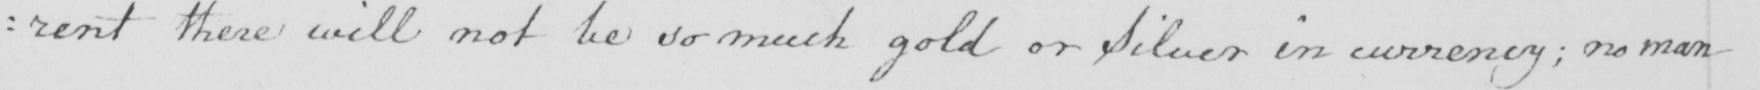What is written in this line of handwriting? : rent there will not be so much gold or Silver in currency ; no man 